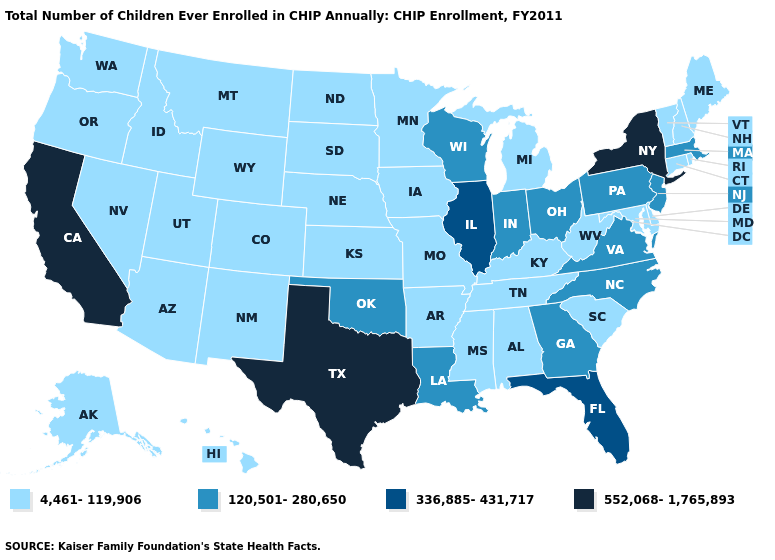What is the lowest value in the West?
Answer briefly. 4,461-119,906. What is the value of Hawaii?
Keep it brief. 4,461-119,906. What is the lowest value in states that border New Jersey?
Keep it brief. 4,461-119,906. Does the map have missing data?
Quick response, please. No. What is the value of Idaho?
Be succinct. 4,461-119,906. Does the first symbol in the legend represent the smallest category?
Answer briefly. Yes. Which states hav the highest value in the Northeast?
Give a very brief answer. New York. Name the states that have a value in the range 336,885-431,717?
Short answer required. Florida, Illinois. Does Iowa have a higher value than Washington?
Be succinct. No. Does Kentucky have the highest value in the South?
Be succinct. No. Which states hav the highest value in the Northeast?
Be succinct. New York. Among the states that border Delaware , does Maryland have the lowest value?
Keep it brief. Yes. Does Kentucky have a higher value than Hawaii?
Concise answer only. No. Name the states that have a value in the range 336,885-431,717?
Be succinct. Florida, Illinois. Does California have the highest value in the West?
Keep it brief. Yes. 